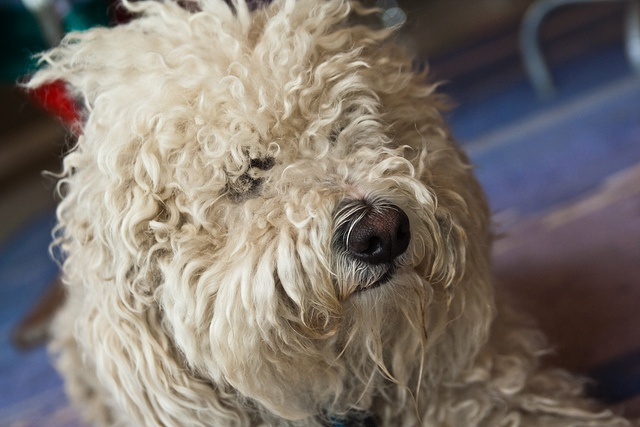Describe the objects in this image and their specific colors. I can see a dog in navy, gray, tan, and lightgray tones in this image. 